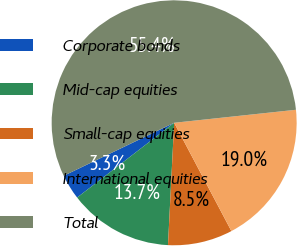Convert chart. <chart><loc_0><loc_0><loc_500><loc_500><pie_chart><fcel>Corporate bonds<fcel>Mid-cap equities<fcel>Small-cap equities<fcel>International equities<fcel>Total<nl><fcel>3.33%<fcel>13.75%<fcel>8.54%<fcel>18.96%<fcel>55.43%<nl></chart> 